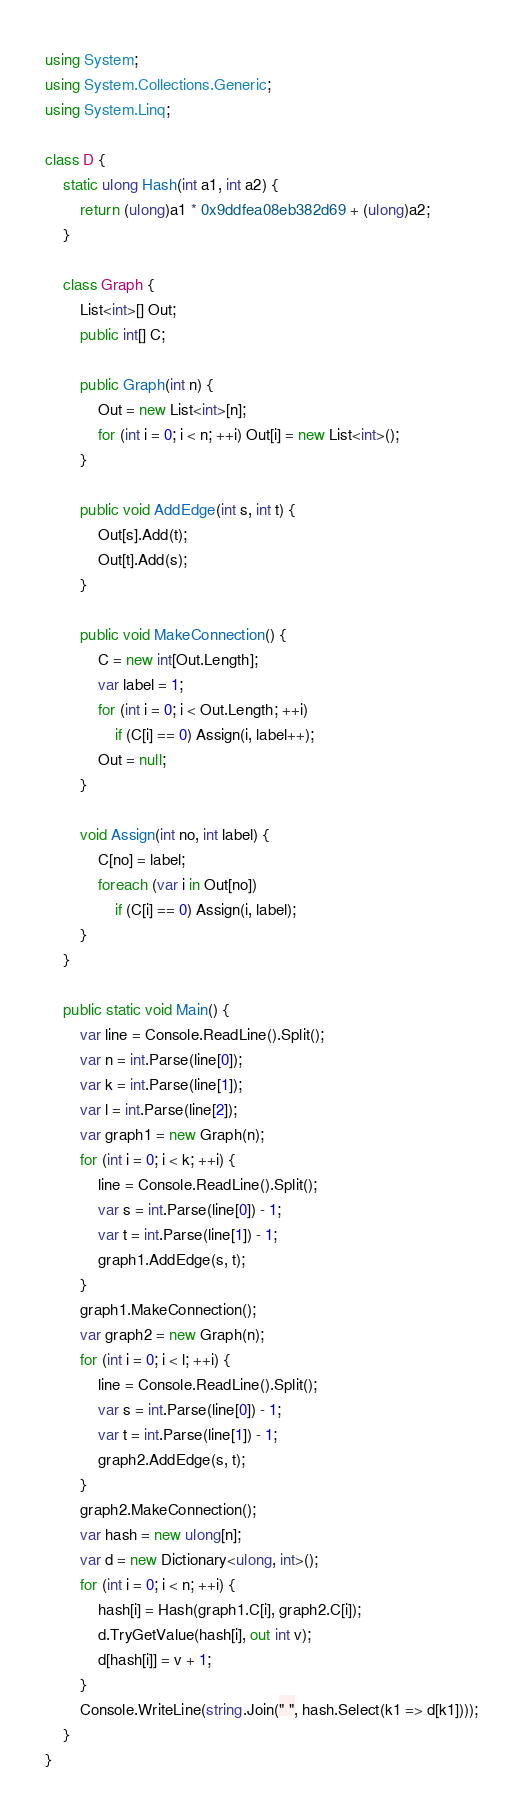Convert code to text. <code><loc_0><loc_0><loc_500><loc_500><_C#_>using System;
using System.Collections.Generic;
using System.Linq;

class D {
    static ulong Hash(int a1, int a2) {
        return (ulong)a1 * 0x9ddfea08eb382d69 + (ulong)a2;
    }

    class Graph {
        List<int>[] Out;
        public int[] C;

        public Graph(int n) {
            Out = new List<int>[n];
            for (int i = 0; i < n; ++i) Out[i] = new List<int>();
        }

        public void AddEdge(int s, int t) {
            Out[s].Add(t);
            Out[t].Add(s);
        }

        public void MakeConnection() {
            C = new int[Out.Length];
            var label = 1;
            for (int i = 0; i < Out.Length; ++i)
                if (C[i] == 0) Assign(i, label++);
            Out = null;
        }

        void Assign(int no, int label) {
            C[no] = label;
            foreach (var i in Out[no])
                if (C[i] == 0) Assign(i, label);
        }
    }

    public static void Main() {
        var line = Console.ReadLine().Split();
        var n = int.Parse(line[0]);
        var k = int.Parse(line[1]);
        var l = int.Parse(line[2]);
        var graph1 = new Graph(n);
        for (int i = 0; i < k; ++i) {
            line = Console.ReadLine().Split();
            var s = int.Parse(line[0]) - 1;
            var t = int.Parse(line[1]) - 1;
            graph1.AddEdge(s, t);
        }
        graph1.MakeConnection();
        var graph2 = new Graph(n);
        for (int i = 0; i < l; ++i) {
            line = Console.ReadLine().Split();
            var s = int.Parse(line[0]) - 1;
            var t = int.Parse(line[1]) - 1;
            graph2.AddEdge(s, t);
        }
        graph2.MakeConnection();
        var hash = new ulong[n];
        var d = new Dictionary<ulong, int>();
        for (int i = 0; i < n; ++i) {
            hash[i] = Hash(graph1.C[i], graph2.C[i]);
            d.TryGetValue(hash[i], out int v);
            d[hash[i]] = v + 1;
        }
        Console.WriteLine(string.Join(" ", hash.Select(k1 => d[k1])));
    }
}
</code> 